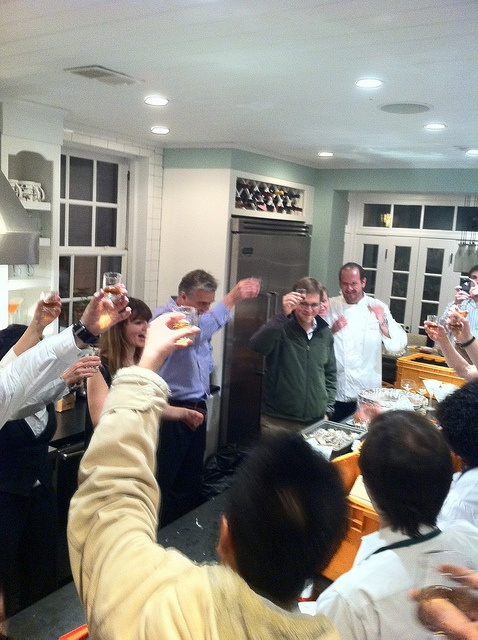Describe the objects in this image and their specific colors. I can see people in darkgray, black, khaki, beige, and tan tones, people in darkgray, black, and lightgray tones, refrigerator in darkgray, black, and gray tones, people in darkgray, black, gray, and brown tones, and people in darkgray, black, gray, and brown tones in this image. 